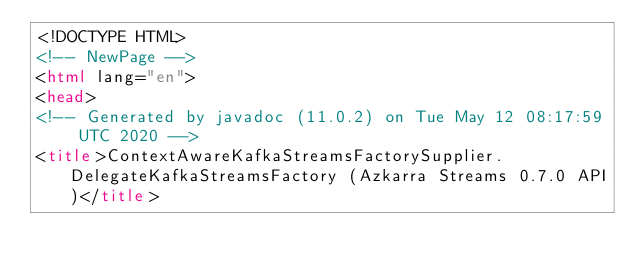Convert code to text. <code><loc_0><loc_0><loc_500><loc_500><_HTML_><!DOCTYPE HTML>
<!-- NewPage -->
<html lang="en">
<head>
<!-- Generated by javadoc (11.0.2) on Tue May 12 08:17:59 UTC 2020 -->
<title>ContextAwareKafkaStreamsFactorySupplier.DelegateKafkaStreamsFactory (Azkarra Streams 0.7.0 API)</title></code> 